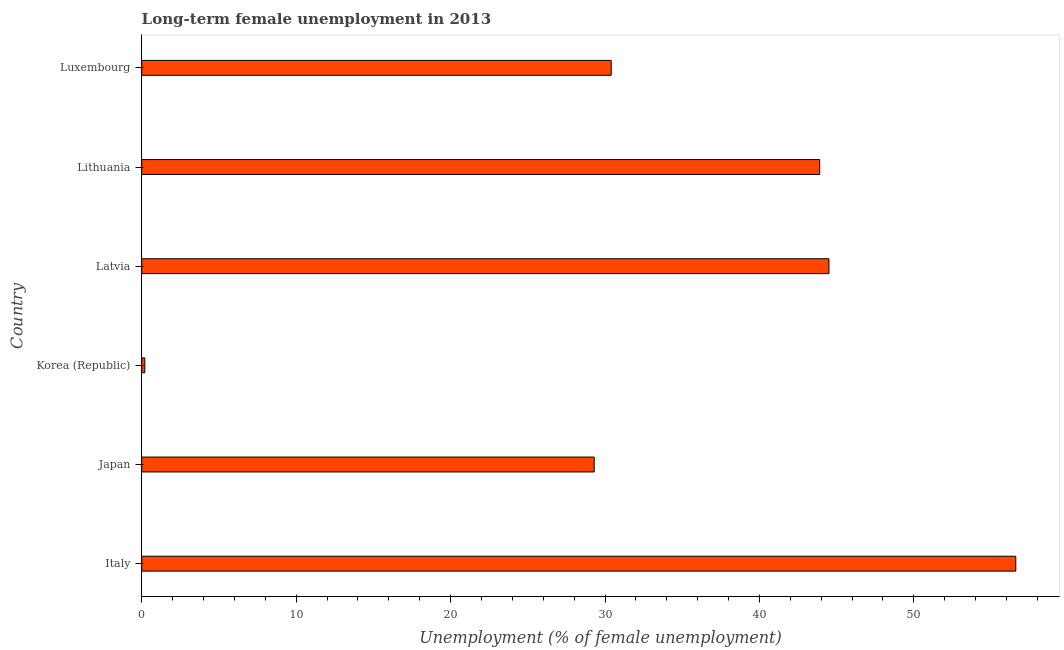Does the graph contain any zero values?
Provide a succinct answer. No. Does the graph contain grids?
Provide a short and direct response. No. What is the title of the graph?
Your answer should be compact. Long-term female unemployment in 2013. What is the label or title of the X-axis?
Your response must be concise. Unemployment (% of female unemployment). What is the long-term female unemployment in Japan?
Ensure brevity in your answer.  29.3. Across all countries, what is the maximum long-term female unemployment?
Your answer should be compact. 56.6. Across all countries, what is the minimum long-term female unemployment?
Give a very brief answer. 0.2. What is the sum of the long-term female unemployment?
Give a very brief answer. 204.9. What is the difference between the long-term female unemployment in Japan and Latvia?
Your response must be concise. -15.2. What is the average long-term female unemployment per country?
Your answer should be very brief. 34.15. What is the median long-term female unemployment?
Offer a very short reply. 37.15. What is the ratio of the long-term female unemployment in Italy to that in Luxembourg?
Provide a succinct answer. 1.86. Is the long-term female unemployment in Korea (Republic) less than that in Latvia?
Make the answer very short. Yes. Is the difference between the long-term female unemployment in Korea (Republic) and Latvia greater than the difference between any two countries?
Make the answer very short. No. What is the difference between the highest and the lowest long-term female unemployment?
Give a very brief answer. 56.4. How many bars are there?
Offer a very short reply. 6. How many countries are there in the graph?
Your answer should be compact. 6. What is the difference between two consecutive major ticks on the X-axis?
Provide a succinct answer. 10. What is the Unemployment (% of female unemployment) of Italy?
Provide a short and direct response. 56.6. What is the Unemployment (% of female unemployment) in Japan?
Provide a short and direct response. 29.3. What is the Unemployment (% of female unemployment) of Korea (Republic)?
Keep it short and to the point. 0.2. What is the Unemployment (% of female unemployment) in Latvia?
Keep it short and to the point. 44.5. What is the Unemployment (% of female unemployment) of Lithuania?
Give a very brief answer. 43.9. What is the Unemployment (% of female unemployment) in Luxembourg?
Your response must be concise. 30.4. What is the difference between the Unemployment (% of female unemployment) in Italy and Japan?
Ensure brevity in your answer.  27.3. What is the difference between the Unemployment (% of female unemployment) in Italy and Korea (Republic)?
Make the answer very short. 56.4. What is the difference between the Unemployment (% of female unemployment) in Italy and Luxembourg?
Provide a succinct answer. 26.2. What is the difference between the Unemployment (% of female unemployment) in Japan and Korea (Republic)?
Make the answer very short. 29.1. What is the difference between the Unemployment (% of female unemployment) in Japan and Latvia?
Give a very brief answer. -15.2. What is the difference between the Unemployment (% of female unemployment) in Japan and Lithuania?
Your response must be concise. -14.6. What is the difference between the Unemployment (% of female unemployment) in Japan and Luxembourg?
Your answer should be very brief. -1.1. What is the difference between the Unemployment (% of female unemployment) in Korea (Republic) and Latvia?
Provide a short and direct response. -44.3. What is the difference between the Unemployment (% of female unemployment) in Korea (Republic) and Lithuania?
Your answer should be very brief. -43.7. What is the difference between the Unemployment (% of female unemployment) in Korea (Republic) and Luxembourg?
Keep it short and to the point. -30.2. What is the difference between the Unemployment (% of female unemployment) in Latvia and Lithuania?
Offer a very short reply. 0.6. What is the difference between the Unemployment (% of female unemployment) in Latvia and Luxembourg?
Make the answer very short. 14.1. What is the ratio of the Unemployment (% of female unemployment) in Italy to that in Japan?
Give a very brief answer. 1.93. What is the ratio of the Unemployment (% of female unemployment) in Italy to that in Korea (Republic)?
Give a very brief answer. 283. What is the ratio of the Unemployment (% of female unemployment) in Italy to that in Latvia?
Offer a very short reply. 1.27. What is the ratio of the Unemployment (% of female unemployment) in Italy to that in Lithuania?
Ensure brevity in your answer.  1.29. What is the ratio of the Unemployment (% of female unemployment) in Italy to that in Luxembourg?
Provide a succinct answer. 1.86. What is the ratio of the Unemployment (% of female unemployment) in Japan to that in Korea (Republic)?
Your answer should be compact. 146.5. What is the ratio of the Unemployment (% of female unemployment) in Japan to that in Latvia?
Make the answer very short. 0.66. What is the ratio of the Unemployment (% of female unemployment) in Japan to that in Lithuania?
Ensure brevity in your answer.  0.67. What is the ratio of the Unemployment (% of female unemployment) in Japan to that in Luxembourg?
Offer a terse response. 0.96. What is the ratio of the Unemployment (% of female unemployment) in Korea (Republic) to that in Latvia?
Offer a very short reply. 0. What is the ratio of the Unemployment (% of female unemployment) in Korea (Republic) to that in Lithuania?
Your answer should be very brief. 0.01. What is the ratio of the Unemployment (% of female unemployment) in Korea (Republic) to that in Luxembourg?
Make the answer very short. 0.01. What is the ratio of the Unemployment (% of female unemployment) in Latvia to that in Luxembourg?
Ensure brevity in your answer.  1.46. What is the ratio of the Unemployment (% of female unemployment) in Lithuania to that in Luxembourg?
Provide a succinct answer. 1.44. 